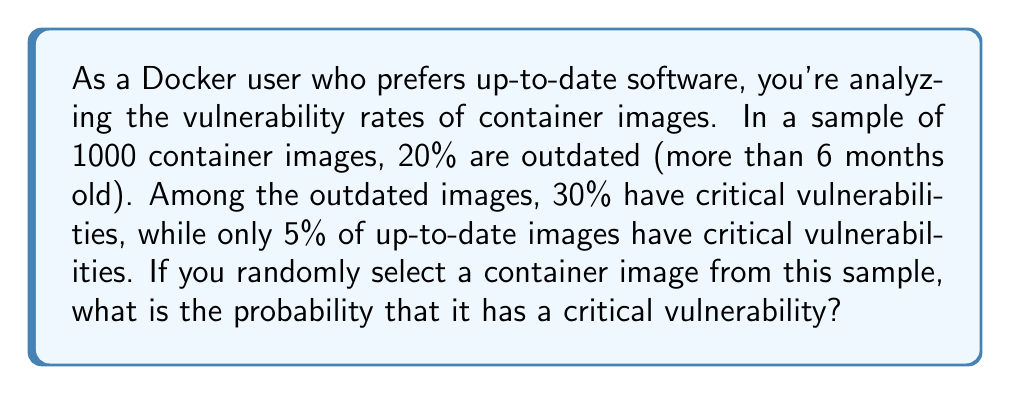Help me with this question. To solve this problem, we'll use the law of total probability. Let's break it down step by step:

1. Define events:
   A: The image has a critical vulnerability
   O: The image is outdated
   U: The image is up-to-date

2. Given probabilities:
   $P(O) = 0.20$ (20% of images are outdated)
   $P(U) = 1 - P(O) = 0.80$ (80% of images are up-to-date)
   $P(A|O) = 0.30$ (30% of outdated images have critical vulnerabilities)
   $P(A|U) = 0.05$ (5% of up-to-date images have critical vulnerabilities)

3. Apply the law of total probability:
   $$P(A) = P(A|O) \cdot P(O) + P(A|U) \cdot P(U)$$

4. Substitute the values:
   $$P(A) = 0.30 \cdot 0.20 + 0.05 \cdot 0.80$$

5. Calculate:
   $$P(A) = 0.06 + 0.04 = 0.10$$

Therefore, the probability that a randomly selected container image has a critical vulnerability is 0.10 or 10%.
Answer: The probability that a randomly selected container image has a critical vulnerability is 0.10 or 10%. 